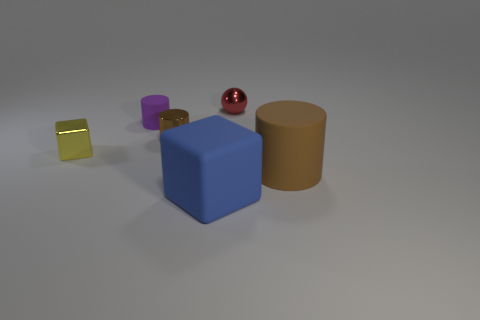Can you describe the atmosphere or mood conveyed by the image? The image conveys a calm and neutral atmosphere, with muted tones and soft lighting. There is no vibrant dynamism or movement, which imparts a static and serene mood to the viewer. 